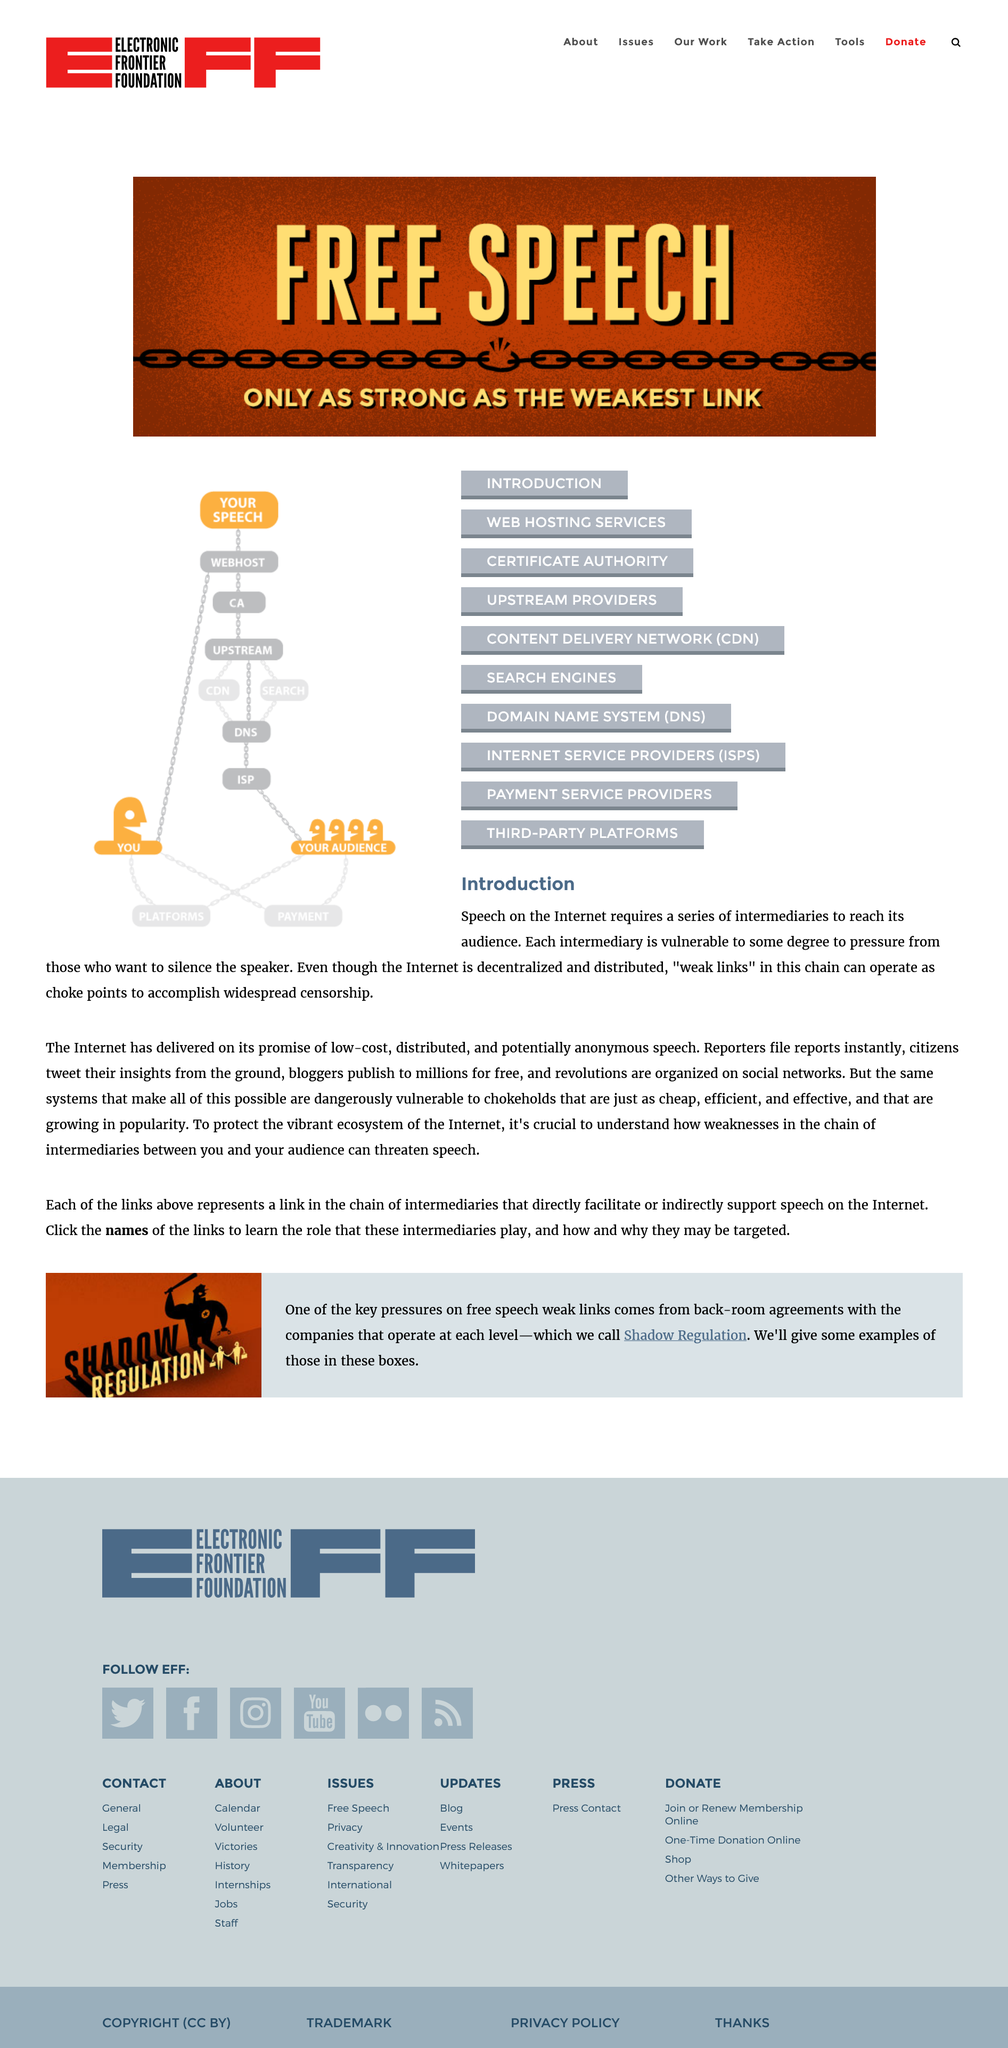Point out several critical features in this image. Content delivery networks are vulnerable to censorship, as they can restrict access to certain content if requested to do so by a governing body or other authority. The delivery of "free speech" on the internet can only occur through a chain of intermediaries. Understanding weak links in the chain of information is crucial to avoid possible censorship. 